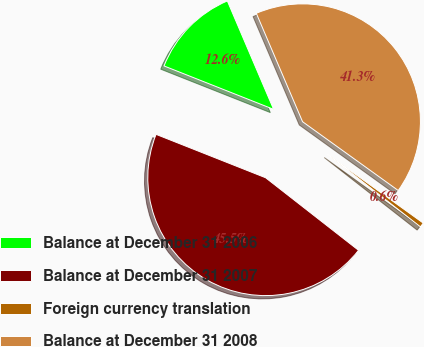Convert chart. <chart><loc_0><loc_0><loc_500><loc_500><pie_chart><fcel>Balance at December 31 2006<fcel>Balance at December 31 2007<fcel>Foreign currency translation<fcel>Balance at December 31 2008<nl><fcel>12.58%<fcel>45.45%<fcel>0.63%<fcel>41.34%<nl></chart> 